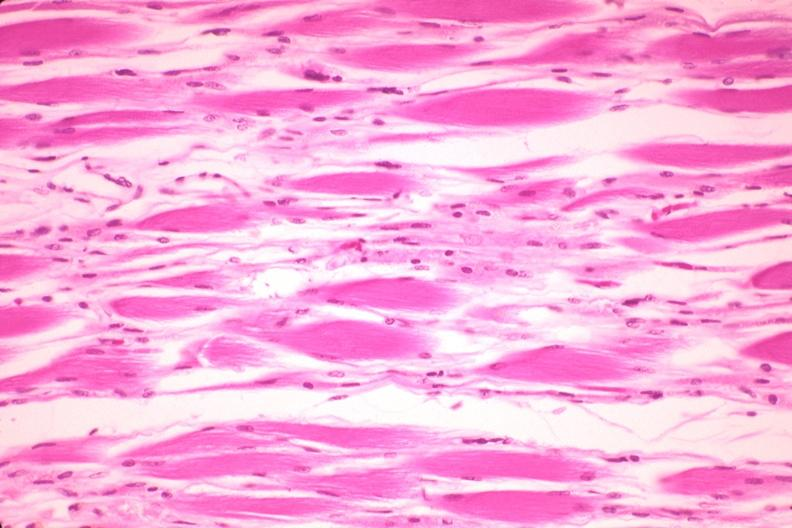what does this image show?
Answer the question using a single word or phrase. High excellent atrophy due to steroid therapy 